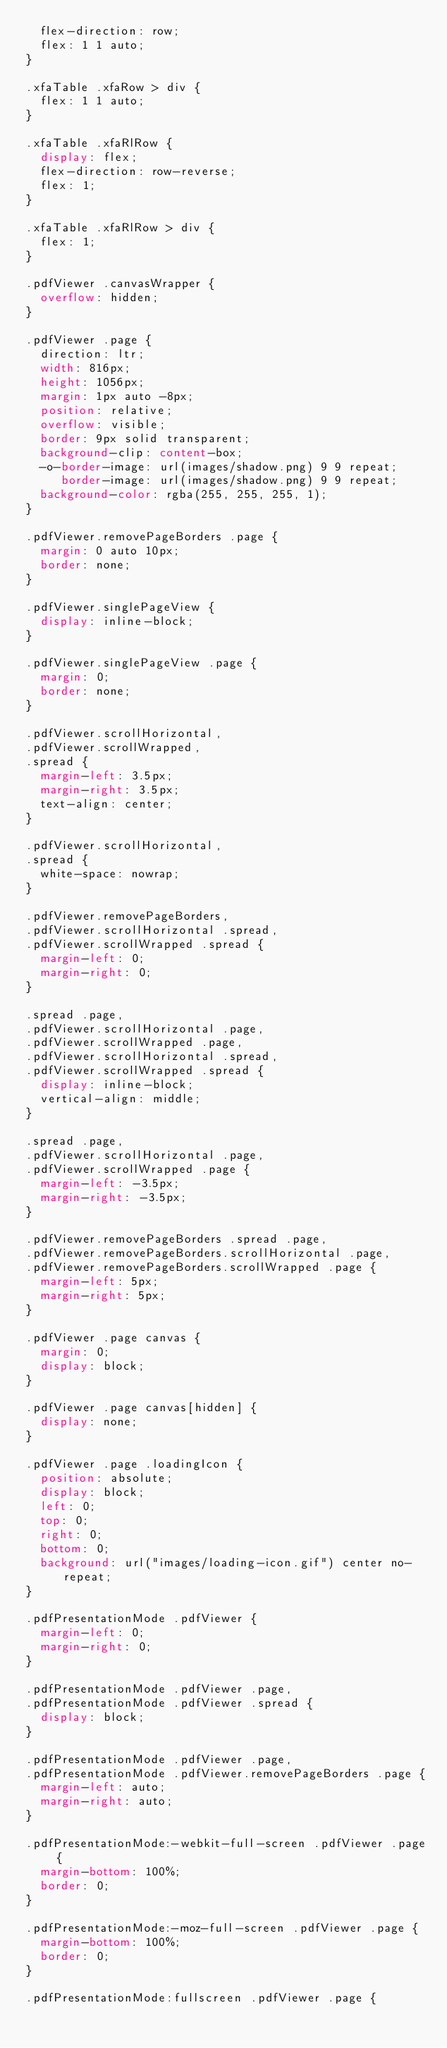Convert code to text. <code><loc_0><loc_0><loc_500><loc_500><_CSS_>  flex-direction: row;
  flex: 1 1 auto;
}

.xfaTable .xfaRow > div {
  flex: 1 1 auto;
}

.xfaTable .xfaRlRow {
  display: flex;
  flex-direction: row-reverse;
  flex: 1;
}

.xfaTable .xfaRlRow > div {
  flex: 1;
}

.pdfViewer .canvasWrapper {
  overflow: hidden;
}

.pdfViewer .page {
  direction: ltr;
  width: 816px;
  height: 1056px;
  margin: 1px auto -8px;
  position: relative;
  overflow: visible;
  border: 9px solid transparent;
  background-clip: content-box;
  -o-border-image: url(images/shadow.png) 9 9 repeat;
     border-image: url(images/shadow.png) 9 9 repeat;
  background-color: rgba(255, 255, 255, 1);
}

.pdfViewer.removePageBorders .page {
  margin: 0 auto 10px;
  border: none;
}

.pdfViewer.singlePageView {
  display: inline-block;
}

.pdfViewer.singlePageView .page {
  margin: 0;
  border: none;
}

.pdfViewer.scrollHorizontal,
.pdfViewer.scrollWrapped,
.spread {
  margin-left: 3.5px;
  margin-right: 3.5px;
  text-align: center;
}

.pdfViewer.scrollHorizontal,
.spread {
  white-space: nowrap;
}

.pdfViewer.removePageBorders,
.pdfViewer.scrollHorizontal .spread,
.pdfViewer.scrollWrapped .spread {
  margin-left: 0;
  margin-right: 0;
}

.spread .page,
.pdfViewer.scrollHorizontal .page,
.pdfViewer.scrollWrapped .page,
.pdfViewer.scrollHorizontal .spread,
.pdfViewer.scrollWrapped .spread {
  display: inline-block;
  vertical-align: middle;
}

.spread .page,
.pdfViewer.scrollHorizontal .page,
.pdfViewer.scrollWrapped .page {
  margin-left: -3.5px;
  margin-right: -3.5px;
}

.pdfViewer.removePageBorders .spread .page,
.pdfViewer.removePageBorders.scrollHorizontal .page,
.pdfViewer.removePageBorders.scrollWrapped .page {
  margin-left: 5px;
  margin-right: 5px;
}

.pdfViewer .page canvas {
  margin: 0;
  display: block;
}

.pdfViewer .page canvas[hidden] {
  display: none;
}

.pdfViewer .page .loadingIcon {
  position: absolute;
  display: block;
  left: 0;
  top: 0;
  right: 0;
  bottom: 0;
  background: url("images/loading-icon.gif") center no-repeat;
}

.pdfPresentationMode .pdfViewer {
  margin-left: 0;
  margin-right: 0;
}

.pdfPresentationMode .pdfViewer .page,
.pdfPresentationMode .pdfViewer .spread {
  display: block;
}

.pdfPresentationMode .pdfViewer .page,
.pdfPresentationMode .pdfViewer.removePageBorders .page {
  margin-left: auto;
  margin-right: auto;
}

.pdfPresentationMode:-webkit-full-screen .pdfViewer .page {
  margin-bottom: 100%;
  border: 0;
}

.pdfPresentationMode:-moz-full-screen .pdfViewer .page {
  margin-bottom: 100%;
  border: 0;
}

.pdfPresentationMode:fullscreen .pdfViewer .page {</code> 